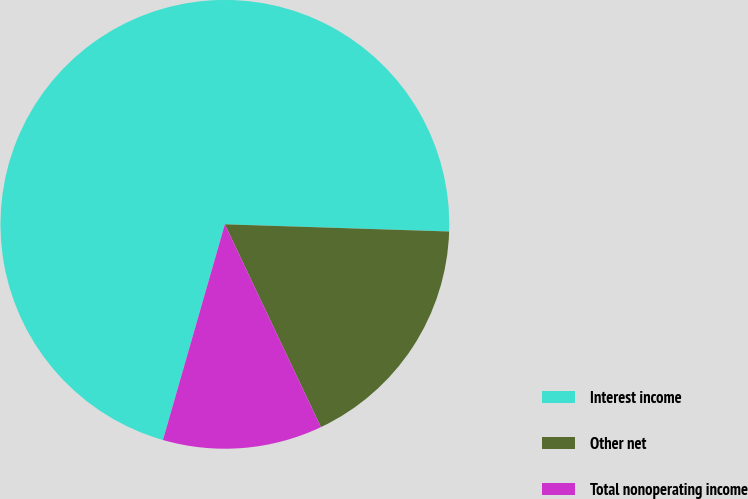Convert chart. <chart><loc_0><loc_0><loc_500><loc_500><pie_chart><fcel>Interest income<fcel>Other net<fcel>Total nonoperating income<nl><fcel>71.06%<fcel>17.45%<fcel>11.49%<nl></chart> 